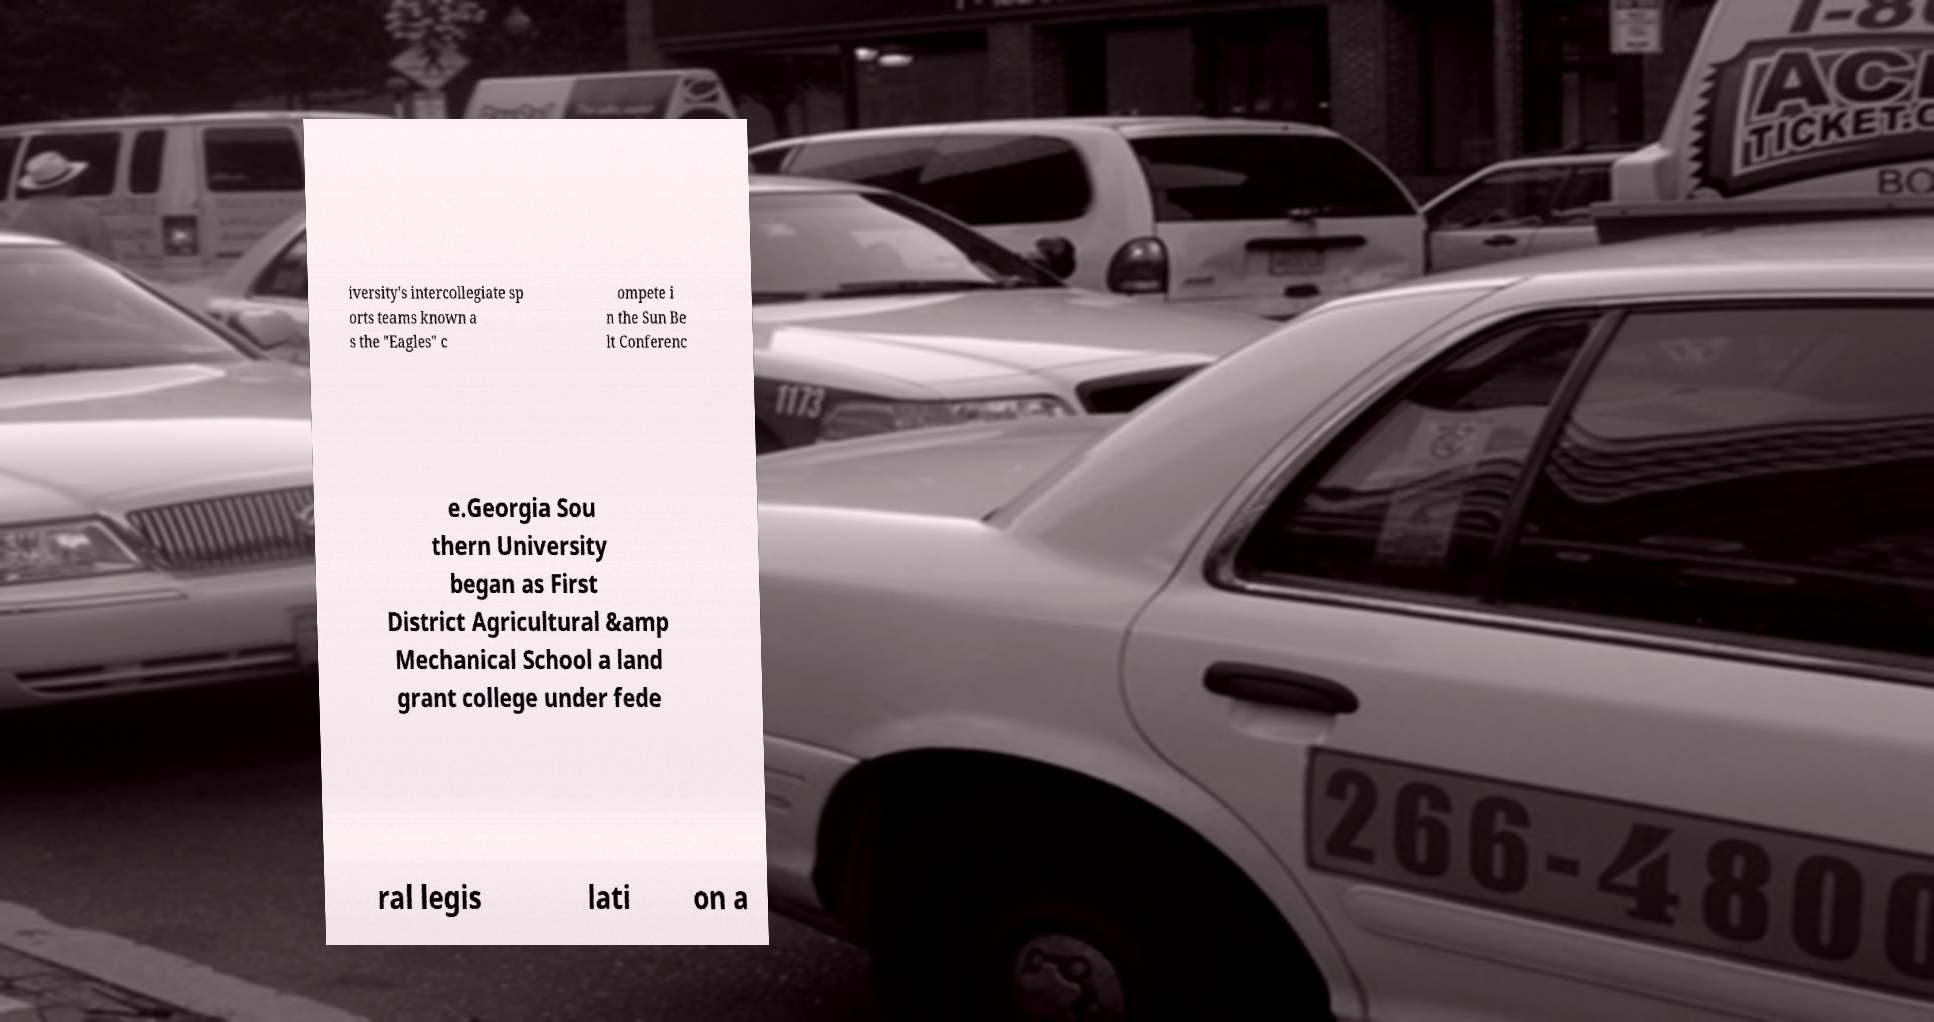I need the written content from this picture converted into text. Can you do that? iversity's intercollegiate sp orts teams known a s the "Eagles" c ompete i n the Sun Be lt Conferenc e.Georgia Sou thern University began as First District Agricultural &amp Mechanical School a land grant college under fede ral legis lati on a 